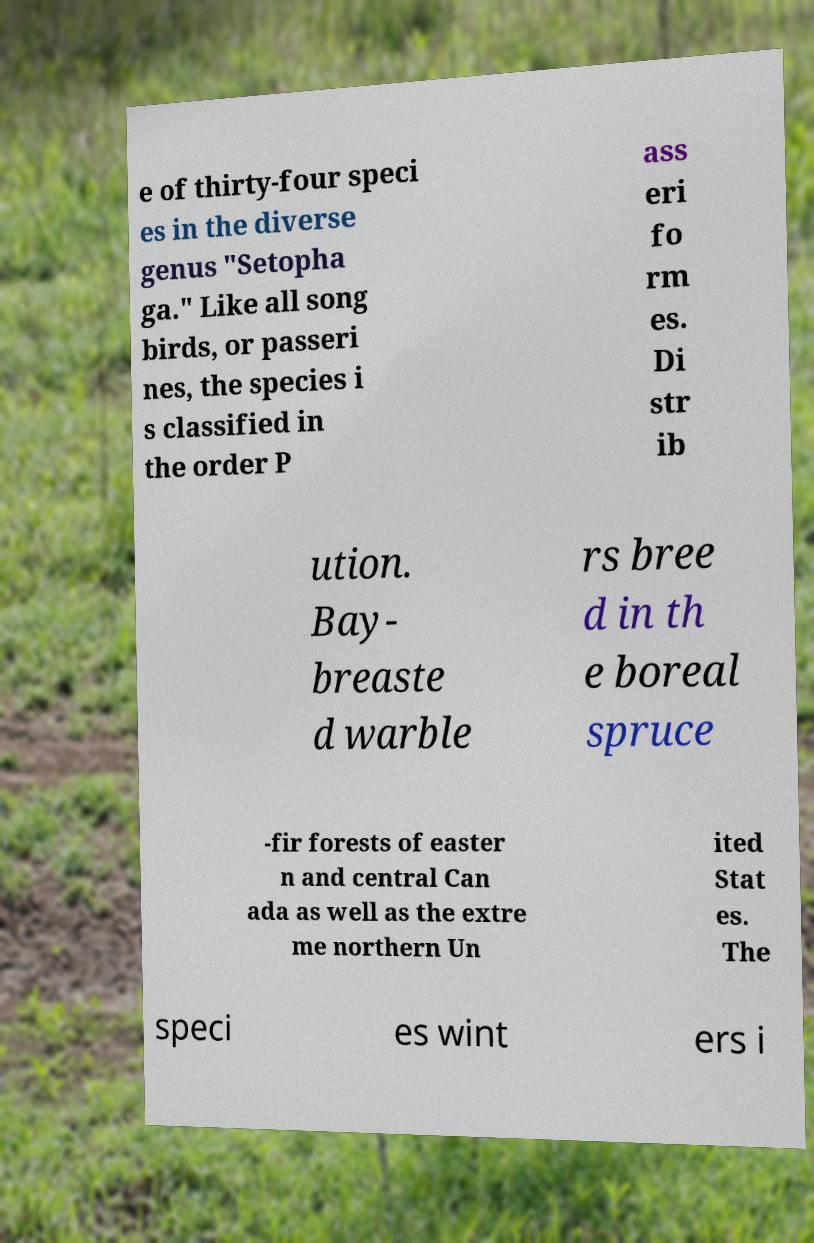What messages or text are displayed in this image? I need them in a readable, typed format. e of thirty-four speci es in the diverse genus "Setopha ga." Like all song birds, or passeri nes, the species i s classified in the order P ass eri fo rm es. Di str ib ution. Bay- breaste d warble rs bree d in th e boreal spruce -fir forests of easter n and central Can ada as well as the extre me northern Un ited Stat es. The speci es wint ers i 